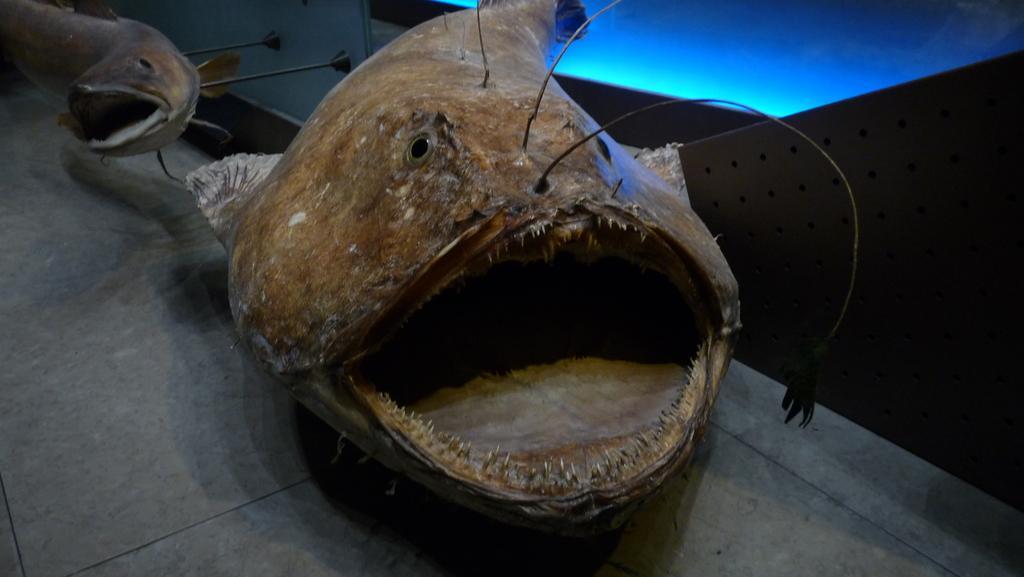In one or two sentences, can you explain what this image depicts? There is a fish. In the back there is a fish mounted on a wall with small rods. 